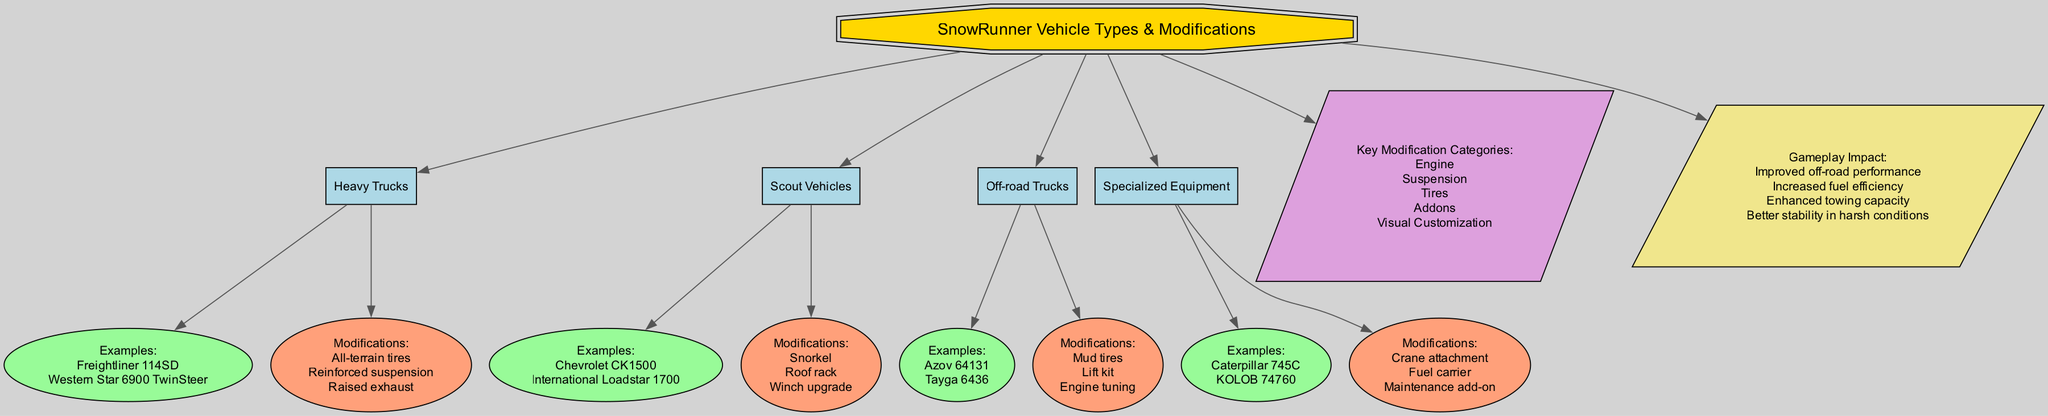What are the examples of Heavy Trucks? By looking at the Heavy Trucks node, the examples listed directly beneath it are "Freightliner 114SD" and "Western Star 6900 TwinSteer."
Answer: Freightliner 114SD, Western Star 6900 TwinSteer How many vehicle types are shown in the diagram? The diagram lists four distinct vehicle types: Heavy Trucks, Scout Vehicles, Off-road Trucks, and Specialized Equipment, which are connected to the main topic.
Answer: 4 What modification is associated with Scout Vehicles? The Scout Vehicles node shows "Snorkel," "Roof rack," and "Winch upgrade" as the modifications directly below it.
Answer: Snorkel, Roof rack, Winch upgrade Which gameplay impact is related to improved off-road performance? Among the listed gameplay impacts, "Improved off-road performance" is explicitly mentioned as one of the impacts connected to the main topic node.
Answer: Improved off-road performance What is the color of the modifications nodes? Each modifications node appears in a distinct color identified in the diagram, which is "light salmon" or "#FFA07A."
Answer: light salmon 